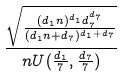<formula> <loc_0><loc_0><loc_500><loc_500>\frac { \sqrt { \frac { ( d _ { 1 } n ) ^ { d _ { 1 } } d _ { 7 } ^ { d _ { 7 } } } { ( d _ { 1 } n + d _ { 7 } ) ^ { d _ { 1 } + d _ { 7 } } } } } { n U ( \frac { d _ { 1 } } { 7 } , \frac { d _ { 7 } } { 7 } ) }</formula> 